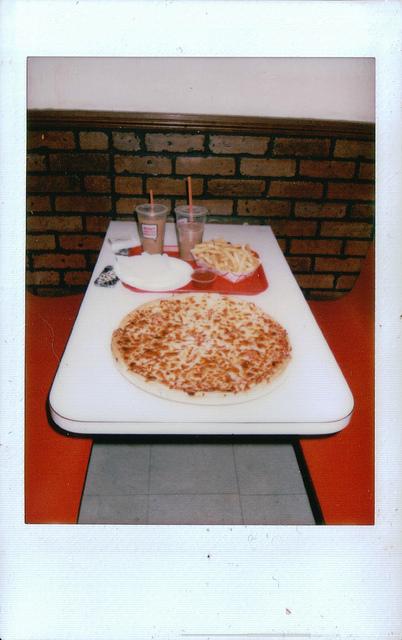Is the meal healthy?
Give a very brief answer. No. How many people is eating this pizza?
Keep it brief. 2. What type of food is that?
Be succinct. Pizza. 